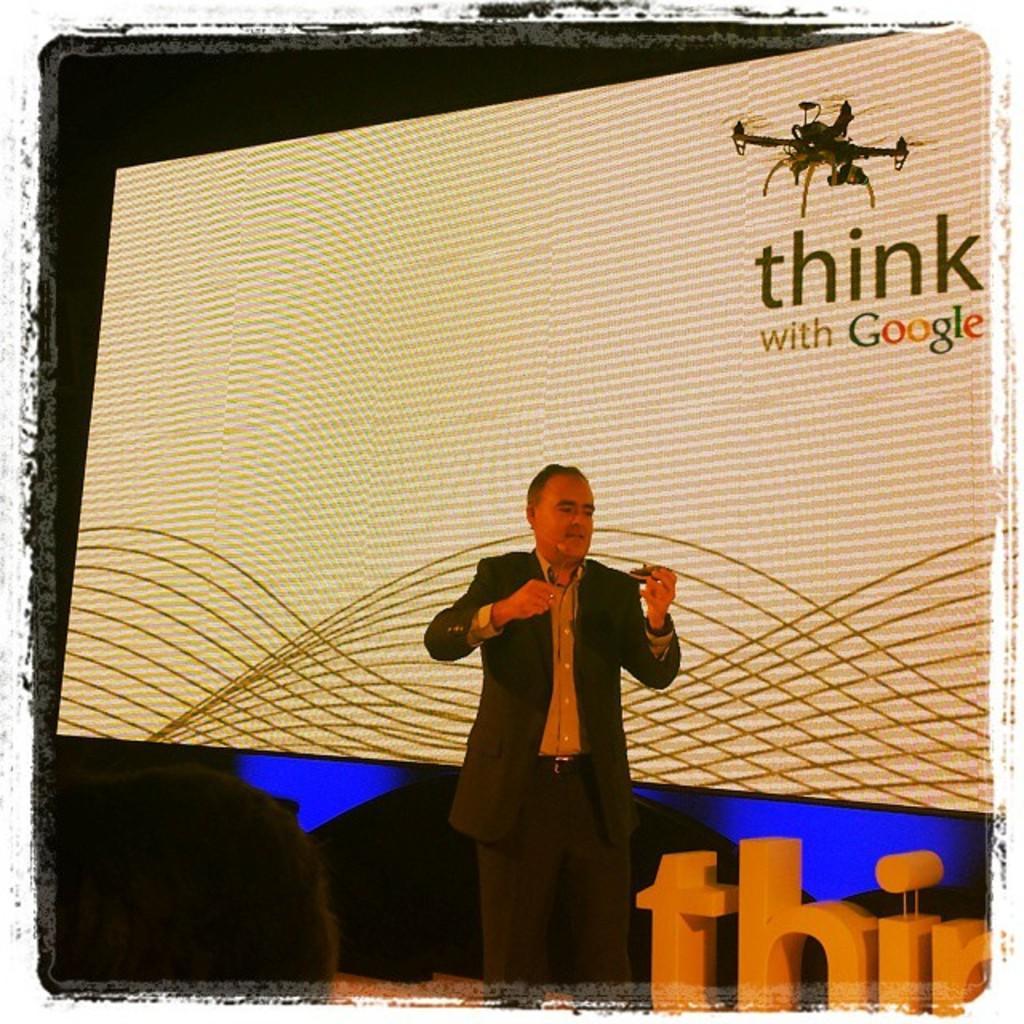Could you give a brief overview of what you see in this image? There is a man standing and talking,behind this man we can see screen,left side of the image we can see person head. In the background it is dark. 